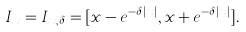Convert formula to latex. <formula><loc_0><loc_0><loc_500><loc_500>I _ { x } = I _ { x , \delta } = [ x - e ^ { - \delta | x | } , x + e ^ { - \delta | x | } ] .</formula> 